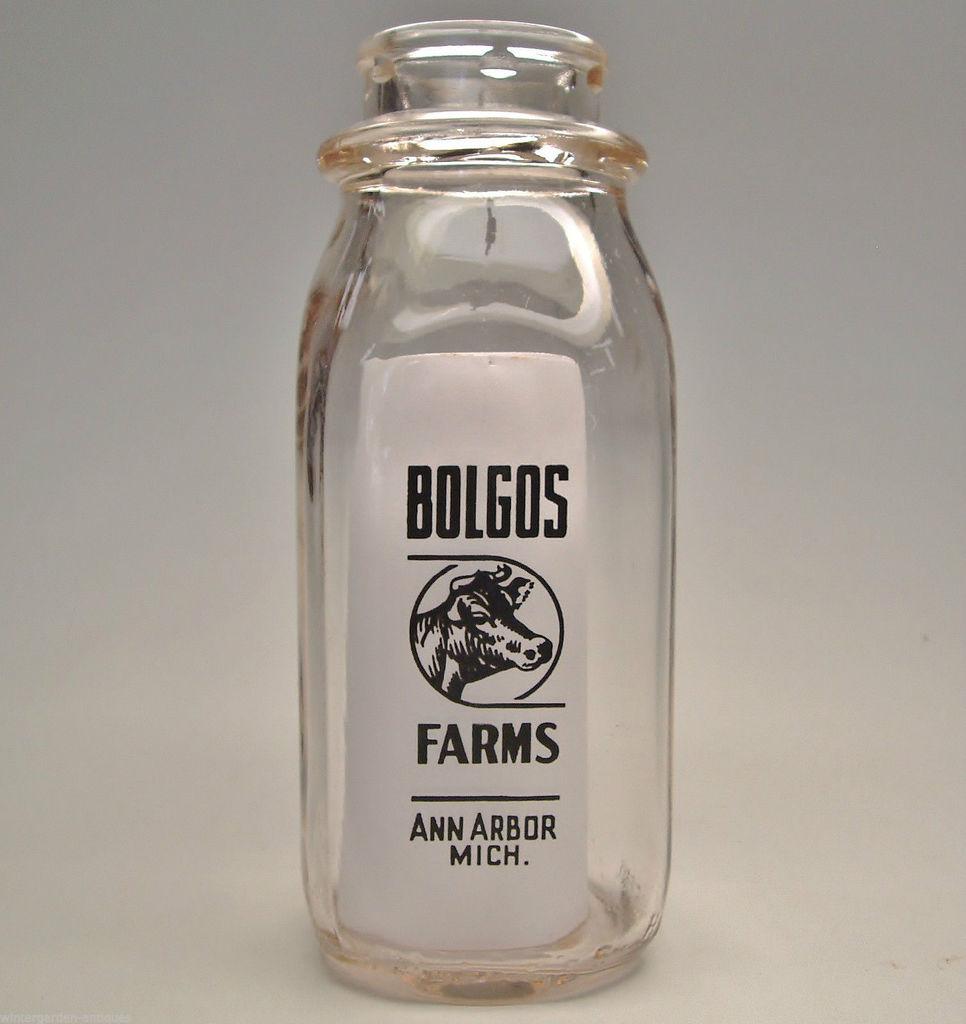From what farm does this bottle come from?
Keep it short and to the point. Bolgos. Where is bolgos farms?
Provide a short and direct response. Ann arbor, michigan. 